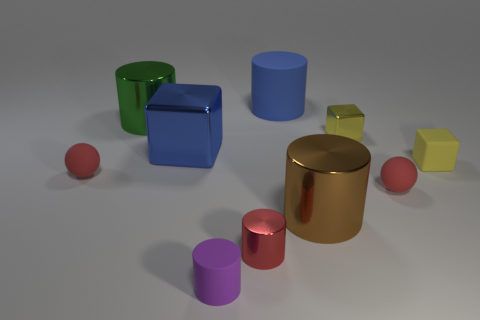There is a rubber object that is behind the yellow rubber cube; does it have the same size as the large green object?
Your response must be concise. Yes. Are there fewer big metal cylinders in front of the big green shiny thing than tiny purple matte cylinders?
Your answer should be compact. No. There is another blue object that is the same size as the blue metal object; what material is it?
Make the answer very short. Rubber. What number of big things are blue spheres or yellow matte blocks?
Provide a succinct answer. 0. What number of things are either small red rubber balls that are left of the large green object or cylinders on the left side of the large metallic block?
Offer a terse response. 2. Are there fewer tiny rubber things than yellow rubber blocks?
Provide a short and direct response. No. There is another yellow thing that is the same size as the yellow matte object; what shape is it?
Ensure brevity in your answer.  Cube. How many other things are the same color as the tiny metal block?
Give a very brief answer. 1. What number of tiny blue cylinders are there?
Offer a very short reply. 0. How many big metallic cylinders are left of the brown metallic cylinder and right of the big green cylinder?
Offer a terse response. 0. 